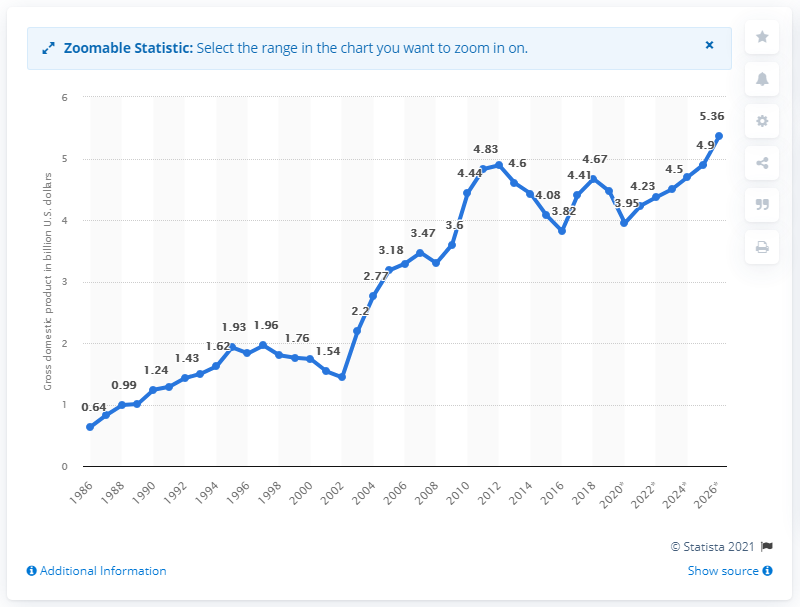Highlight a few significant elements in this photo. In 2019, the gross domestic product (GDP) of Swaziland was 4.5. 